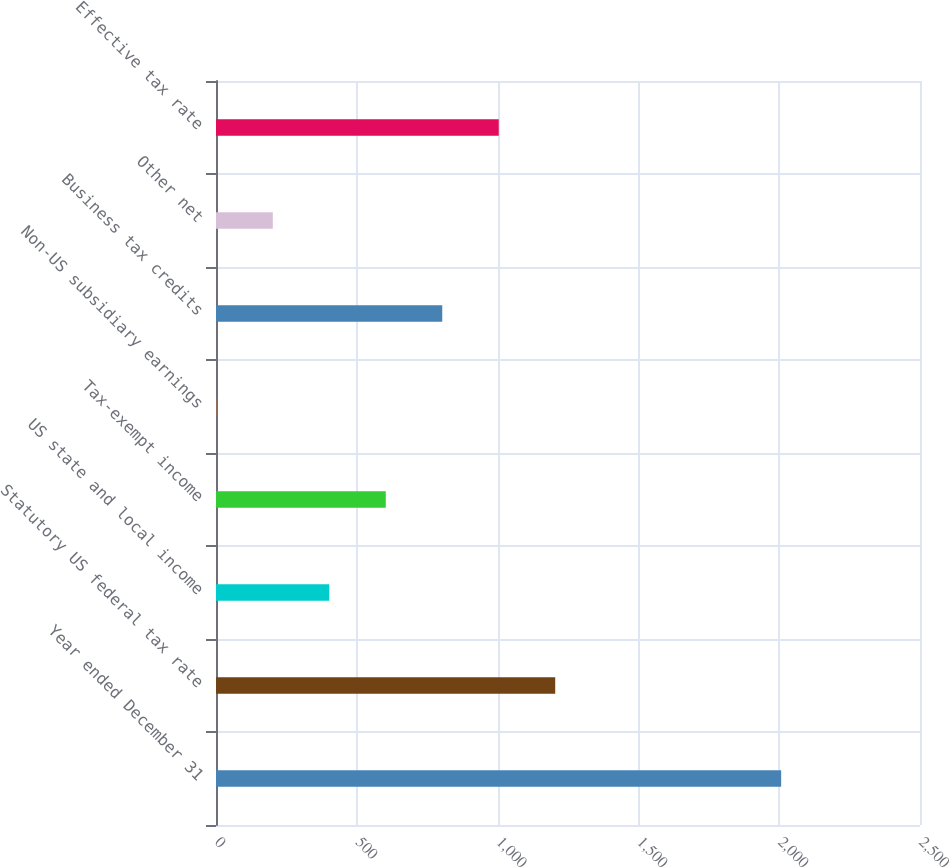Convert chart. <chart><loc_0><loc_0><loc_500><loc_500><bar_chart><fcel>Year ended December 31<fcel>Statutory US federal tax rate<fcel>US state and local income<fcel>Tax-exempt income<fcel>Non-US subsidiary earnings<fcel>Business tax credits<fcel>Other net<fcel>Effective tax rate<nl><fcel>2007<fcel>1204.64<fcel>402.28<fcel>602.87<fcel>1.1<fcel>803.46<fcel>201.69<fcel>1004.05<nl></chart> 